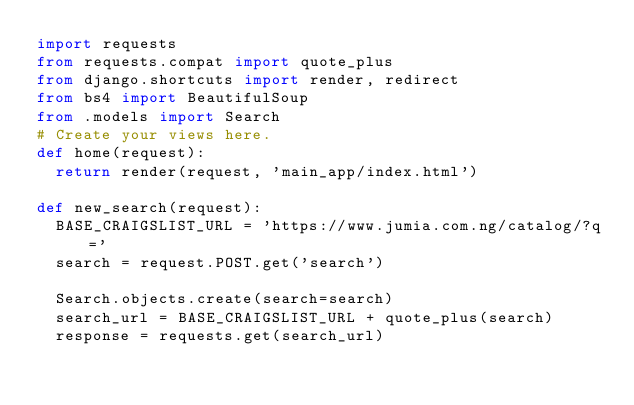Convert code to text. <code><loc_0><loc_0><loc_500><loc_500><_Python_>import requests
from requests.compat import quote_plus
from django.shortcuts import render, redirect
from bs4 import BeautifulSoup
from .models import Search
# Create your views here.
def home(request):
  return render(request, 'main_app/index.html')

def new_search(request):
  BASE_CRAIGSLIST_URL = 'https://www.jumia.com.ng/catalog/?q='
  search = request.POST.get('search')

  Search.objects.create(search=search)
  search_url = BASE_CRAIGSLIST_URL + quote_plus(search)
  response = requests.get(search_url)</code> 